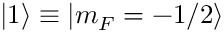<formula> <loc_0><loc_0><loc_500><loc_500>{ | 1 \rangle } \equiv | m _ { F } = - 1 / 2 \rangle</formula> 